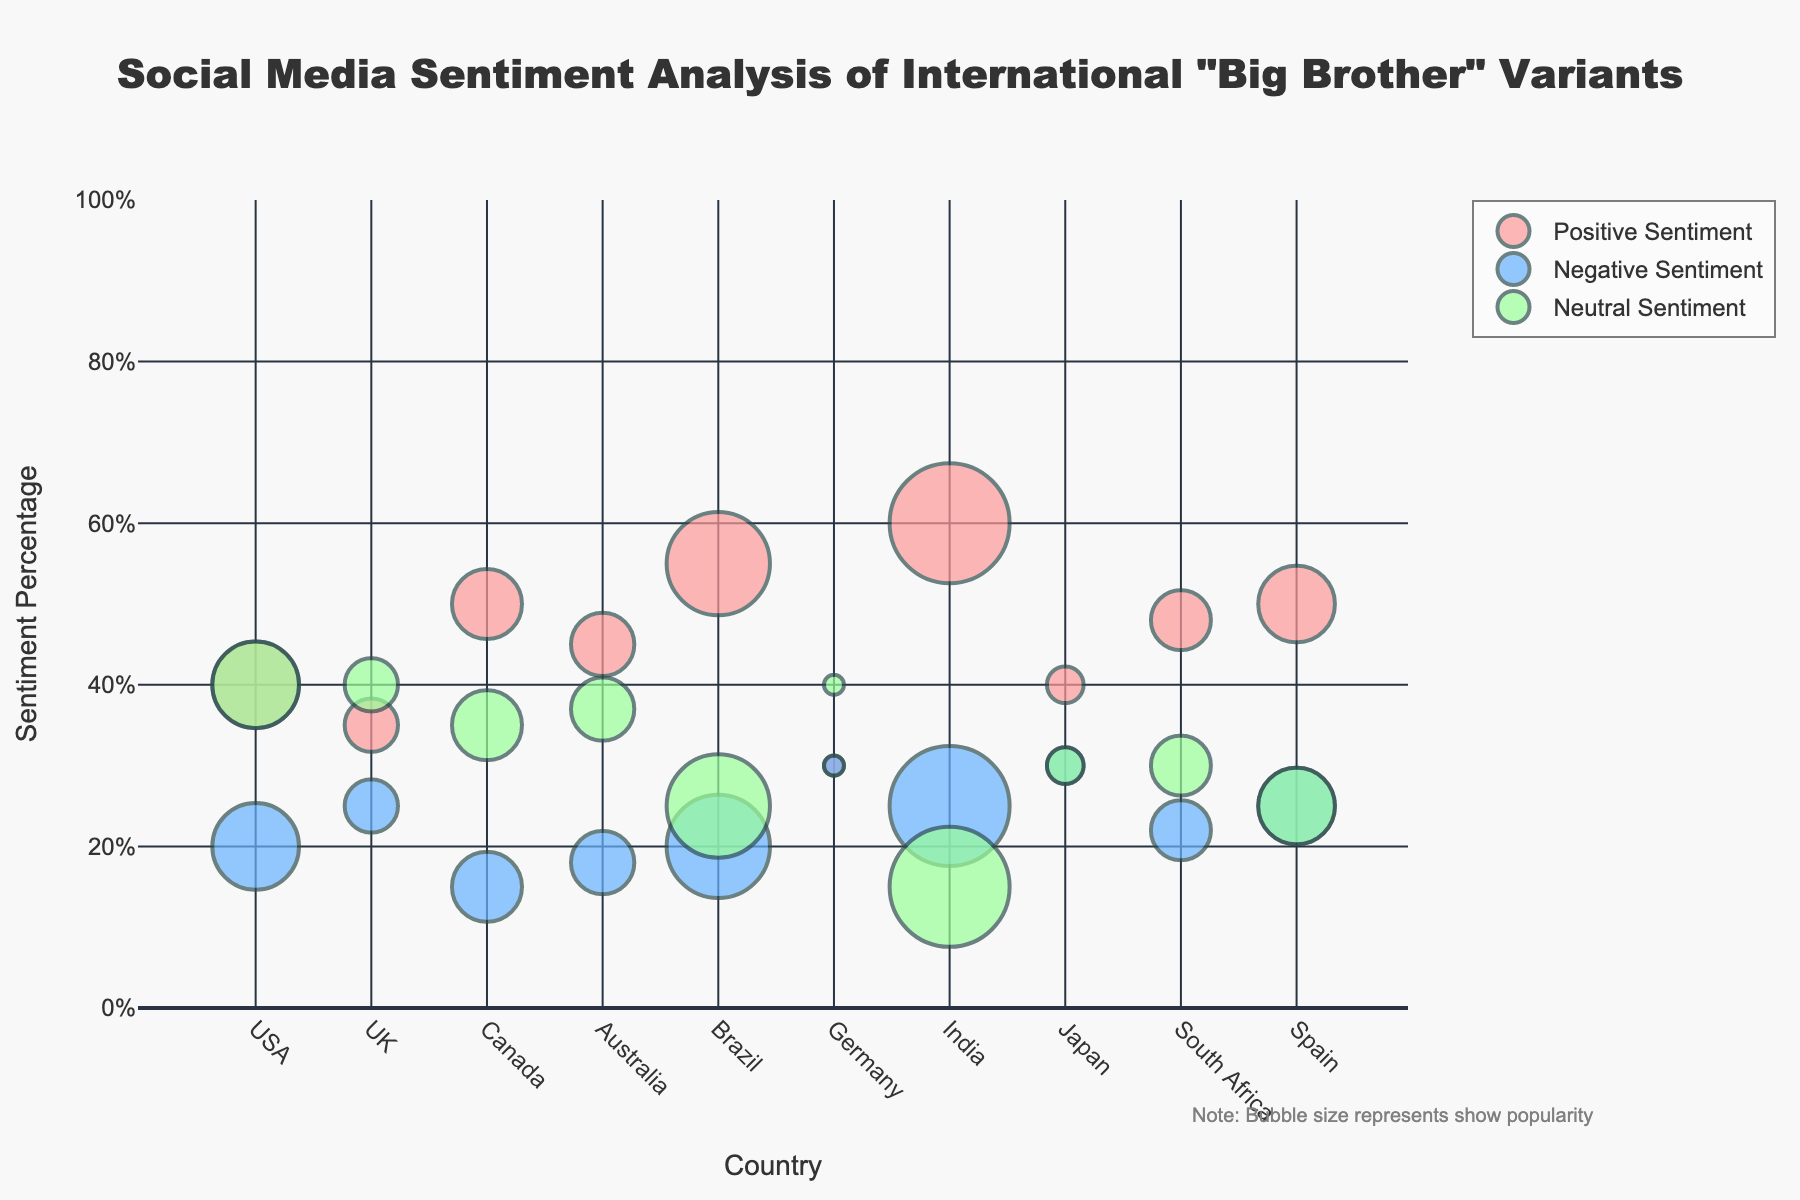What is the most popular variant of "Big Brother" according to the plot? Examine the hover information or the bubble sizes in the plot to see which show variant has the highest overall popularity score. In this case, "Bigg Boss India" has the largest bubble, indicating the highest popularity.
Answer: Bigg Boss India Which country has the highest positive sentiment for their "Big Brother" variant? Look at the y-axis representing positive sentiment and identify the highest data point. According to the plot, India has the highest positive sentiment at 60%.
Answer: India How does "Big Brother US" compare to "Big Brother UK" in terms of negative sentiment? Compare the y-axis values for negative sentiment of "Big Brother US" and "Big Brother UK". "Big Brother US" has a negative sentiment of 20%, whereas "Big Brother UK" has 25%.
Answer: Big Brother UK has higher negative sentiment Which variant has the lowest neutral sentiment? Check the y-axis values for neutral sentiment across all data points. "Bigg Boss India" and "Big Brother Brasil" have the lowest neutral sentiment, both at 15%.
Answer: Bigg Boss India and Big Brother Brasil What is the average positive sentiment for the American, British, and Canadian variants? Add the positive sentiment percentages for "Big Brother US" (40%), "Big Brother UK" (35%), and "Big Brother Canada" (50%). Then divide the sum by 3 to get the average. (40 + 35 + 50) / 3 = 41.67%
Answer: 41.67% Which country has the largest bubble size in the plot? Bubble size represents the popularity score. The country with the largest bubble size will have the highest popularity score. The largest bubble corresponds to India with a popularity score of 95.
Answer: India Is the negative sentiment higher in "Big Brother Germany" or "Big Brother Japan"? Compare the negative sentiment percentages for both variants. "Big Brother Germany" has 30% negative sentiment, while "Big Brother Japan" also has 30% negative sentiment.
Answer: They are equal What is the total negative sentiment for all "Big Brother" variants combined? Add the negative sentiment percentages of all countries (20 + 25 + 15 + 18 + 20 + 30 + 25 + 30 + 22 + 25). The total negative sentiment is 230%.
Answer: 230% In which country is the neutral sentiment higher than the positive sentiment? Compare the positive and neutral sentiment values for each country. Only "Big Brother Japan" has a higher neutral sentiment (30%) than positive sentiment (40%).
Answer: Japan How does "Gran Hermano" perform in terms of popularity compared to "Big Brother Canada"? Compare the bubble sizes representing the popularity scores for both variants. "Gran Hermano" has a popularity score of 82, while "Big Brother Canada" has a score of 80.
Answer: Gran Hermano is slightly more popular 